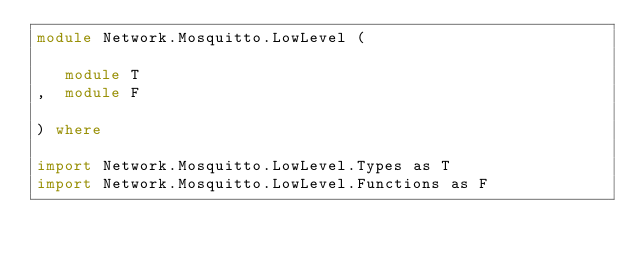<code> <loc_0><loc_0><loc_500><loc_500><_Haskell_>module Network.Mosquitto.LowLevel (

   module T
,  module F

) where

import Network.Mosquitto.LowLevel.Types as T
import Network.Mosquitto.LowLevel.Functions as F
</code> 